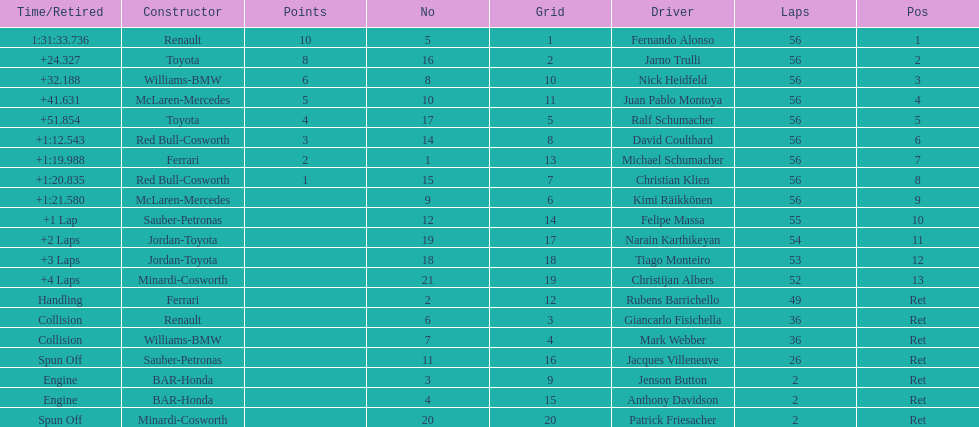How many drivers were retired before the race could end? 7. 